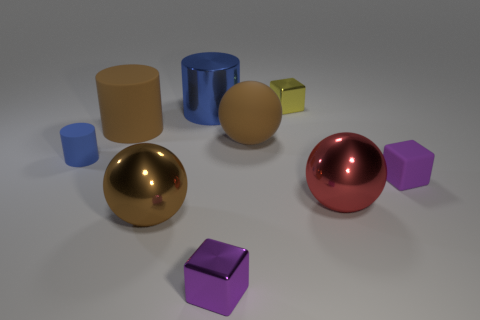Subtract all cylinders. How many objects are left? 6 Subtract all blocks. Subtract all tiny gray metallic cylinders. How many objects are left? 6 Add 5 big brown cylinders. How many big brown cylinders are left? 6 Add 3 brown matte things. How many brown matte things exist? 5 Subtract 0 purple cylinders. How many objects are left? 9 